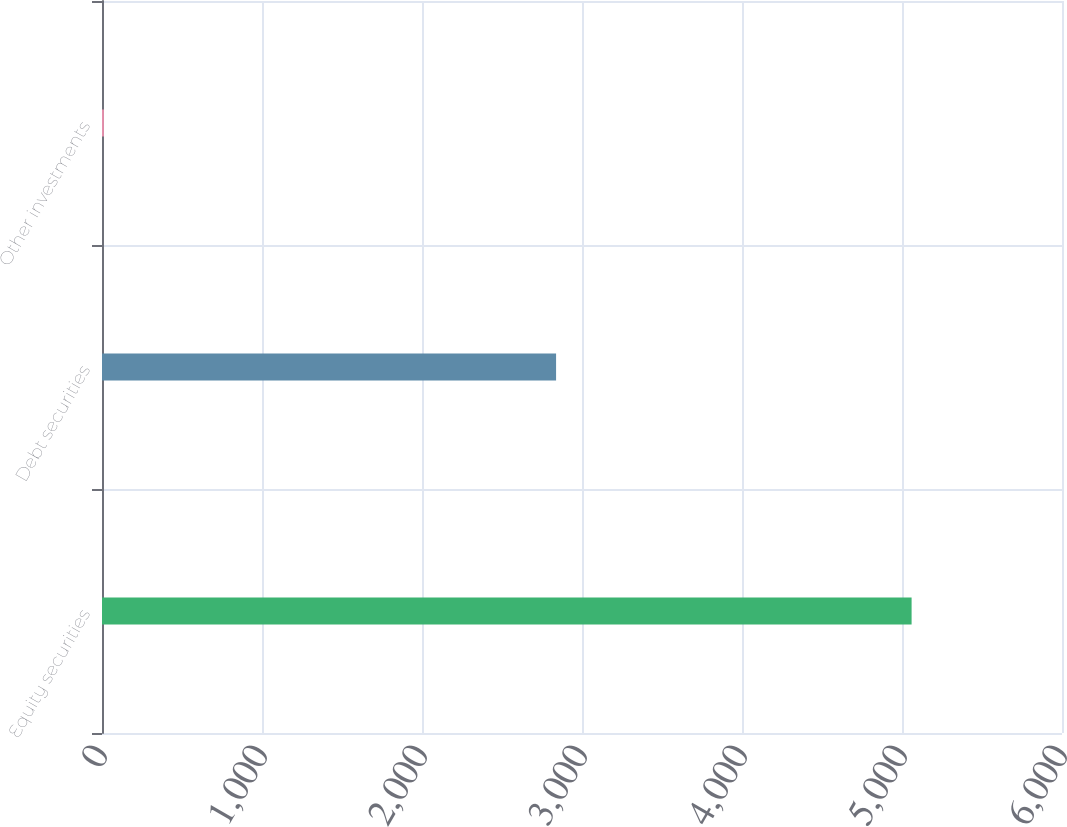Convert chart. <chart><loc_0><loc_0><loc_500><loc_500><bar_chart><fcel>Equity securities<fcel>Debt securities<fcel>Other investments<nl><fcel>5060<fcel>2838<fcel>12<nl></chart> 